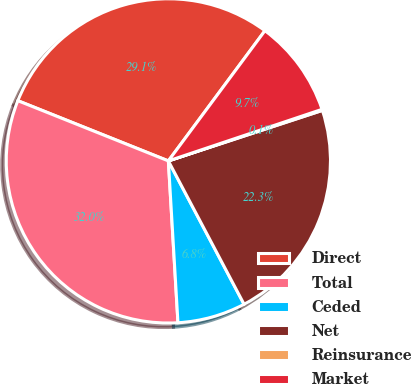<chart> <loc_0><loc_0><loc_500><loc_500><pie_chart><fcel>Direct<fcel>Total<fcel>Ceded<fcel>Net<fcel>Reinsurance<fcel>Market<nl><fcel>29.1%<fcel>32.0%<fcel>6.79%<fcel>22.31%<fcel>0.11%<fcel>9.69%<nl></chart> 